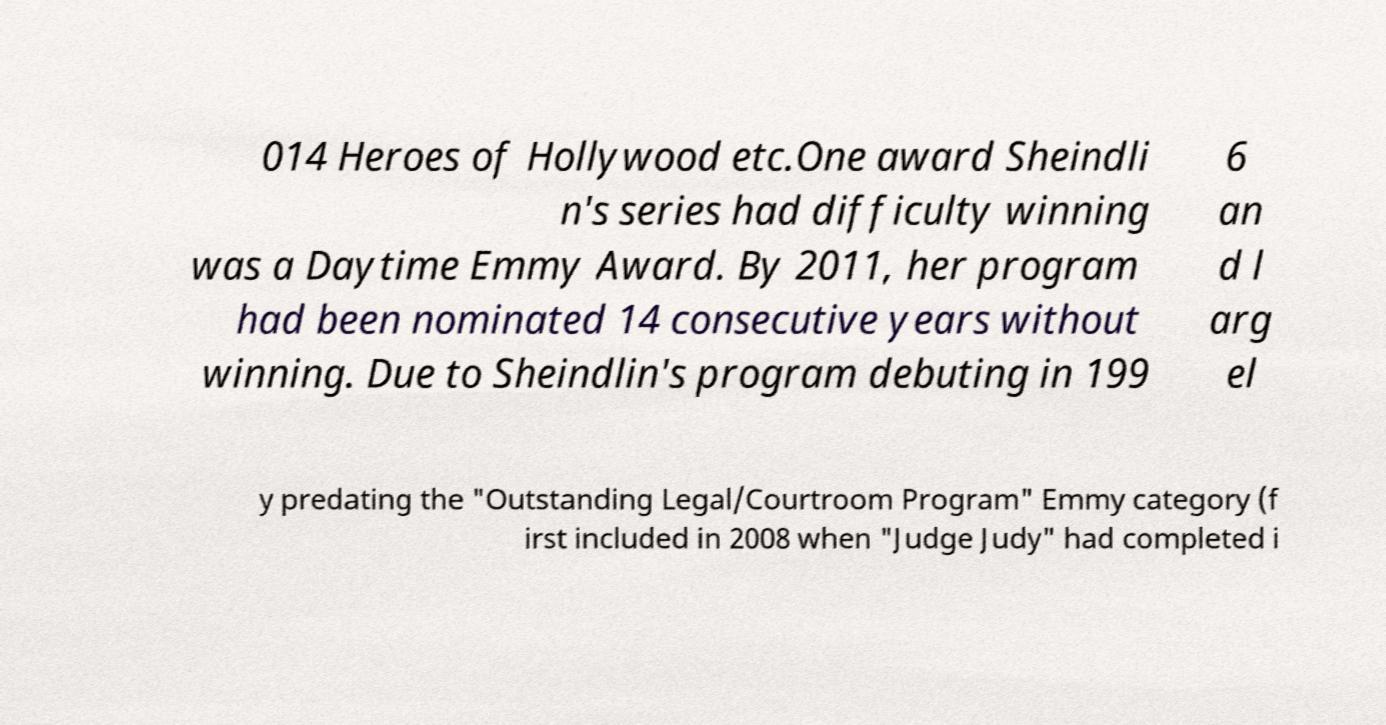There's text embedded in this image that I need extracted. Can you transcribe it verbatim? 014 Heroes of Hollywood etc.One award Sheindli n's series had difficulty winning was a Daytime Emmy Award. By 2011, her program had been nominated 14 consecutive years without winning. Due to Sheindlin's program debuting in 199 6 an d l arg el y predating the "Outstanding Legal/Courtroom Program" Emmy category (f irst included in 2008 when "Judge Judy" had completed i 